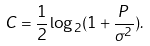Convert formula to latex. <formula><loc_0><loc_0><loc_500><loc_500>C = \frac { 1 } { 2 } \log _ { 2 } ( 1 + \frac { P } { \sigma ^ { 2 } } ) .</formula> 